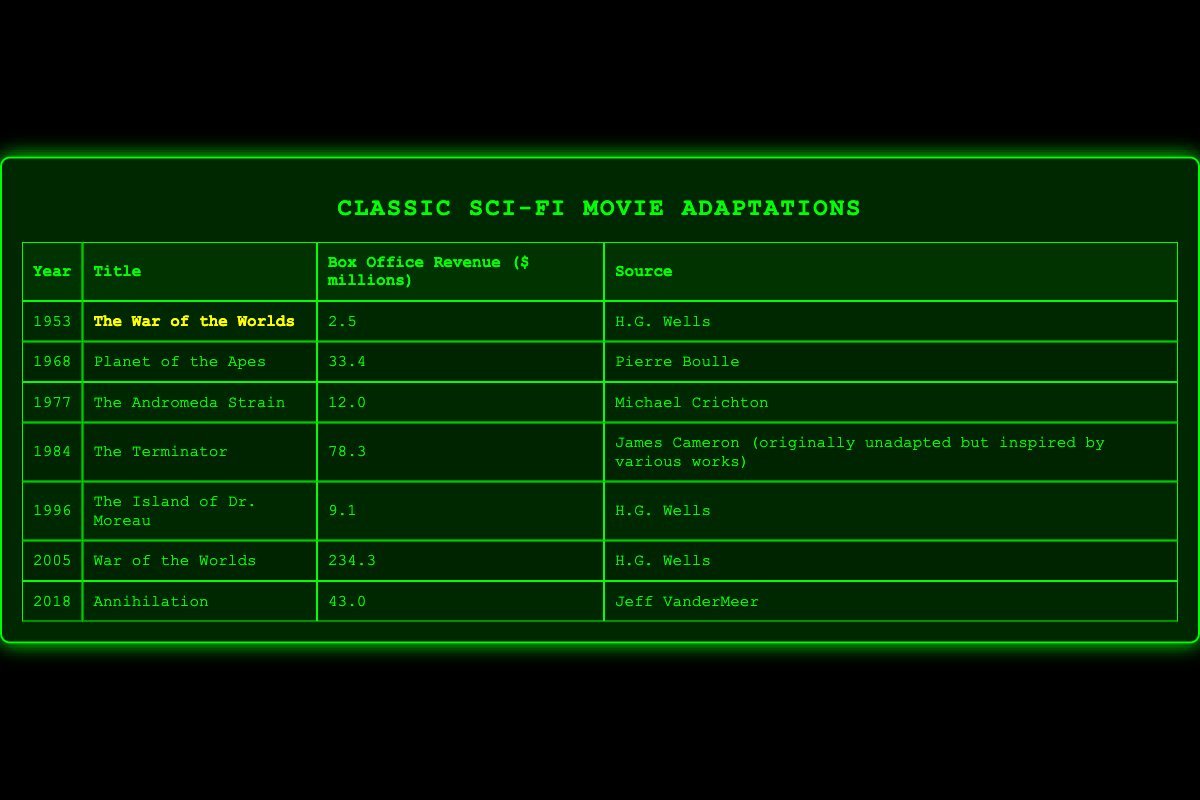What was the box office revenue for "The War of the Worlds" released in 1953? The table lists "The War of the Worlds" in the year 1953 with a box office revenue of 2.5 million dollars.
Answer: 2.5 million dollars Which movie adaptation had the highest box office revenue? By comparing the box office revenues listed, "War of the Worlds" from 2005 shows the highest revenue at 234.3 million dollars.
Answer: War of the Worlds (2005) How many adaptations are based on works by H.G. Wells? The adaptations based on H.G. Wells' works are "The War of the Worlds" (1953), "The Island of Dr. Moreau" (1996), and "War of the Worlds" (2005). Counting these gives us a total of 3 adaptations.
Answer: 3 What is the average box office revenue of the movie adaptations listed? To find the average, sum the revenues (2.5 + 33.4 + 12.0 + 78.3 + 9.1 + 234.3 + 43.0 = 412.2 million dollars) and divide by the number of films (7), which equals 412.2 / 7 = 58.89 million dollars.
Answer: 58.89 million dollars Is "The Terminator" based on a specific literary source? The table indicates that "The Terminator" is inspired by various works but is originally unadapted, so it does not have a specific literary source.
Answer: No Which year saw the release of the adaptation of "Annihilation" and what was its box office revenue? The table shows "Annihilation" was released in 2018 with a box office revenue of 43.0 million dollars.
Answer: 2018, 43.0 million dollars If you consider the years 1953 and 2005, how much more did the 2005 adaptation earn at the box office compared to the 1953 version? The revenue for the 2005 adaptation "War of the Worlds" is 234.3 million dollars, and for the 1953 version is 2.5 million dollars. The difference is 234.3 - 2.5 = 231.8 million dollars.
Answer: 231.8 million dollars Did any adaptations release in the 1990s earn over 10 million dollars? The table lists "The Island of Dr. Moreau" from 1996 with a revenue of 9.1 million dollars, which is less than 10 million dollars. Thus, no adaptations from the 1990s earned over 10 million dollars.
Answer: No What percentage of the total revenue do the adaptations based on H.G. Wells' works represent? H.G. Wells' adaptations earned a total of (2.5 + 9.1 + 234.3 = 245.9 million dollars). The total revenue from all adaptations is 412.2 million dollars. The percentage is (245.9 / 412.2) * 100 ≈ 59.74%.
Answer: 59.74% 